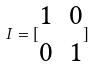<formula> <loc_0><loc_0><loc_500><loc_500>I = [ \begin{matrix} 1 & 0 \\ 0 & 1 \end{matrix} ]</formula> 